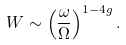Convert formula to latex. <formula><loc_0><loc_0><loc_500><loc_500>W \sim \left ( \frac { \omega } { \Omega } \right ) ^ { 1 - 4 g } .</formula> 